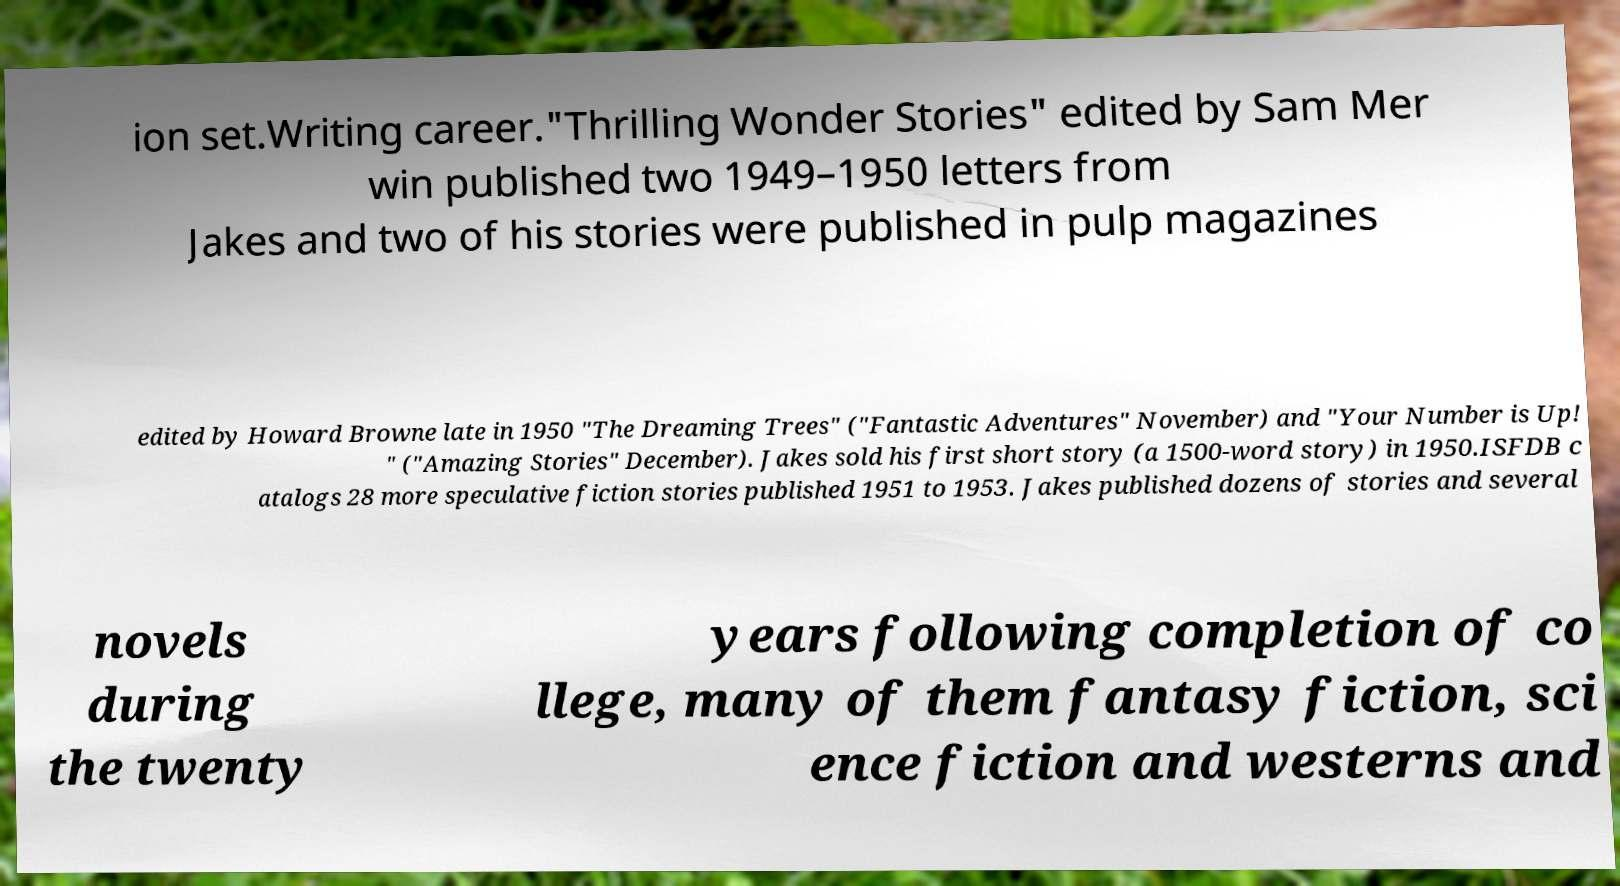Can you accurately transcribe the text from the provided image for me? ion set.Writing career."Thrilling Wonder Stories" edited by Sam Mer win published two 1949–1950 letters from Jakes and two of his stories were published in pulp magazines edited by Howard Browne late in 1950 "The Dreaming Trees" ("Fantastic Adventures" November) and "Your Number is Up! " ("Amazing Stories" December). Jakes sold his first short story (a 1500-word story) in 1950.ISFDB c atalogs 28 more speculative fiction stories published 1951 to 1953. Jakes published dozens of stories and several novels during the twenty years following completion of co llege, many of them fantasy fiction, sci ence fiction and westerns and 